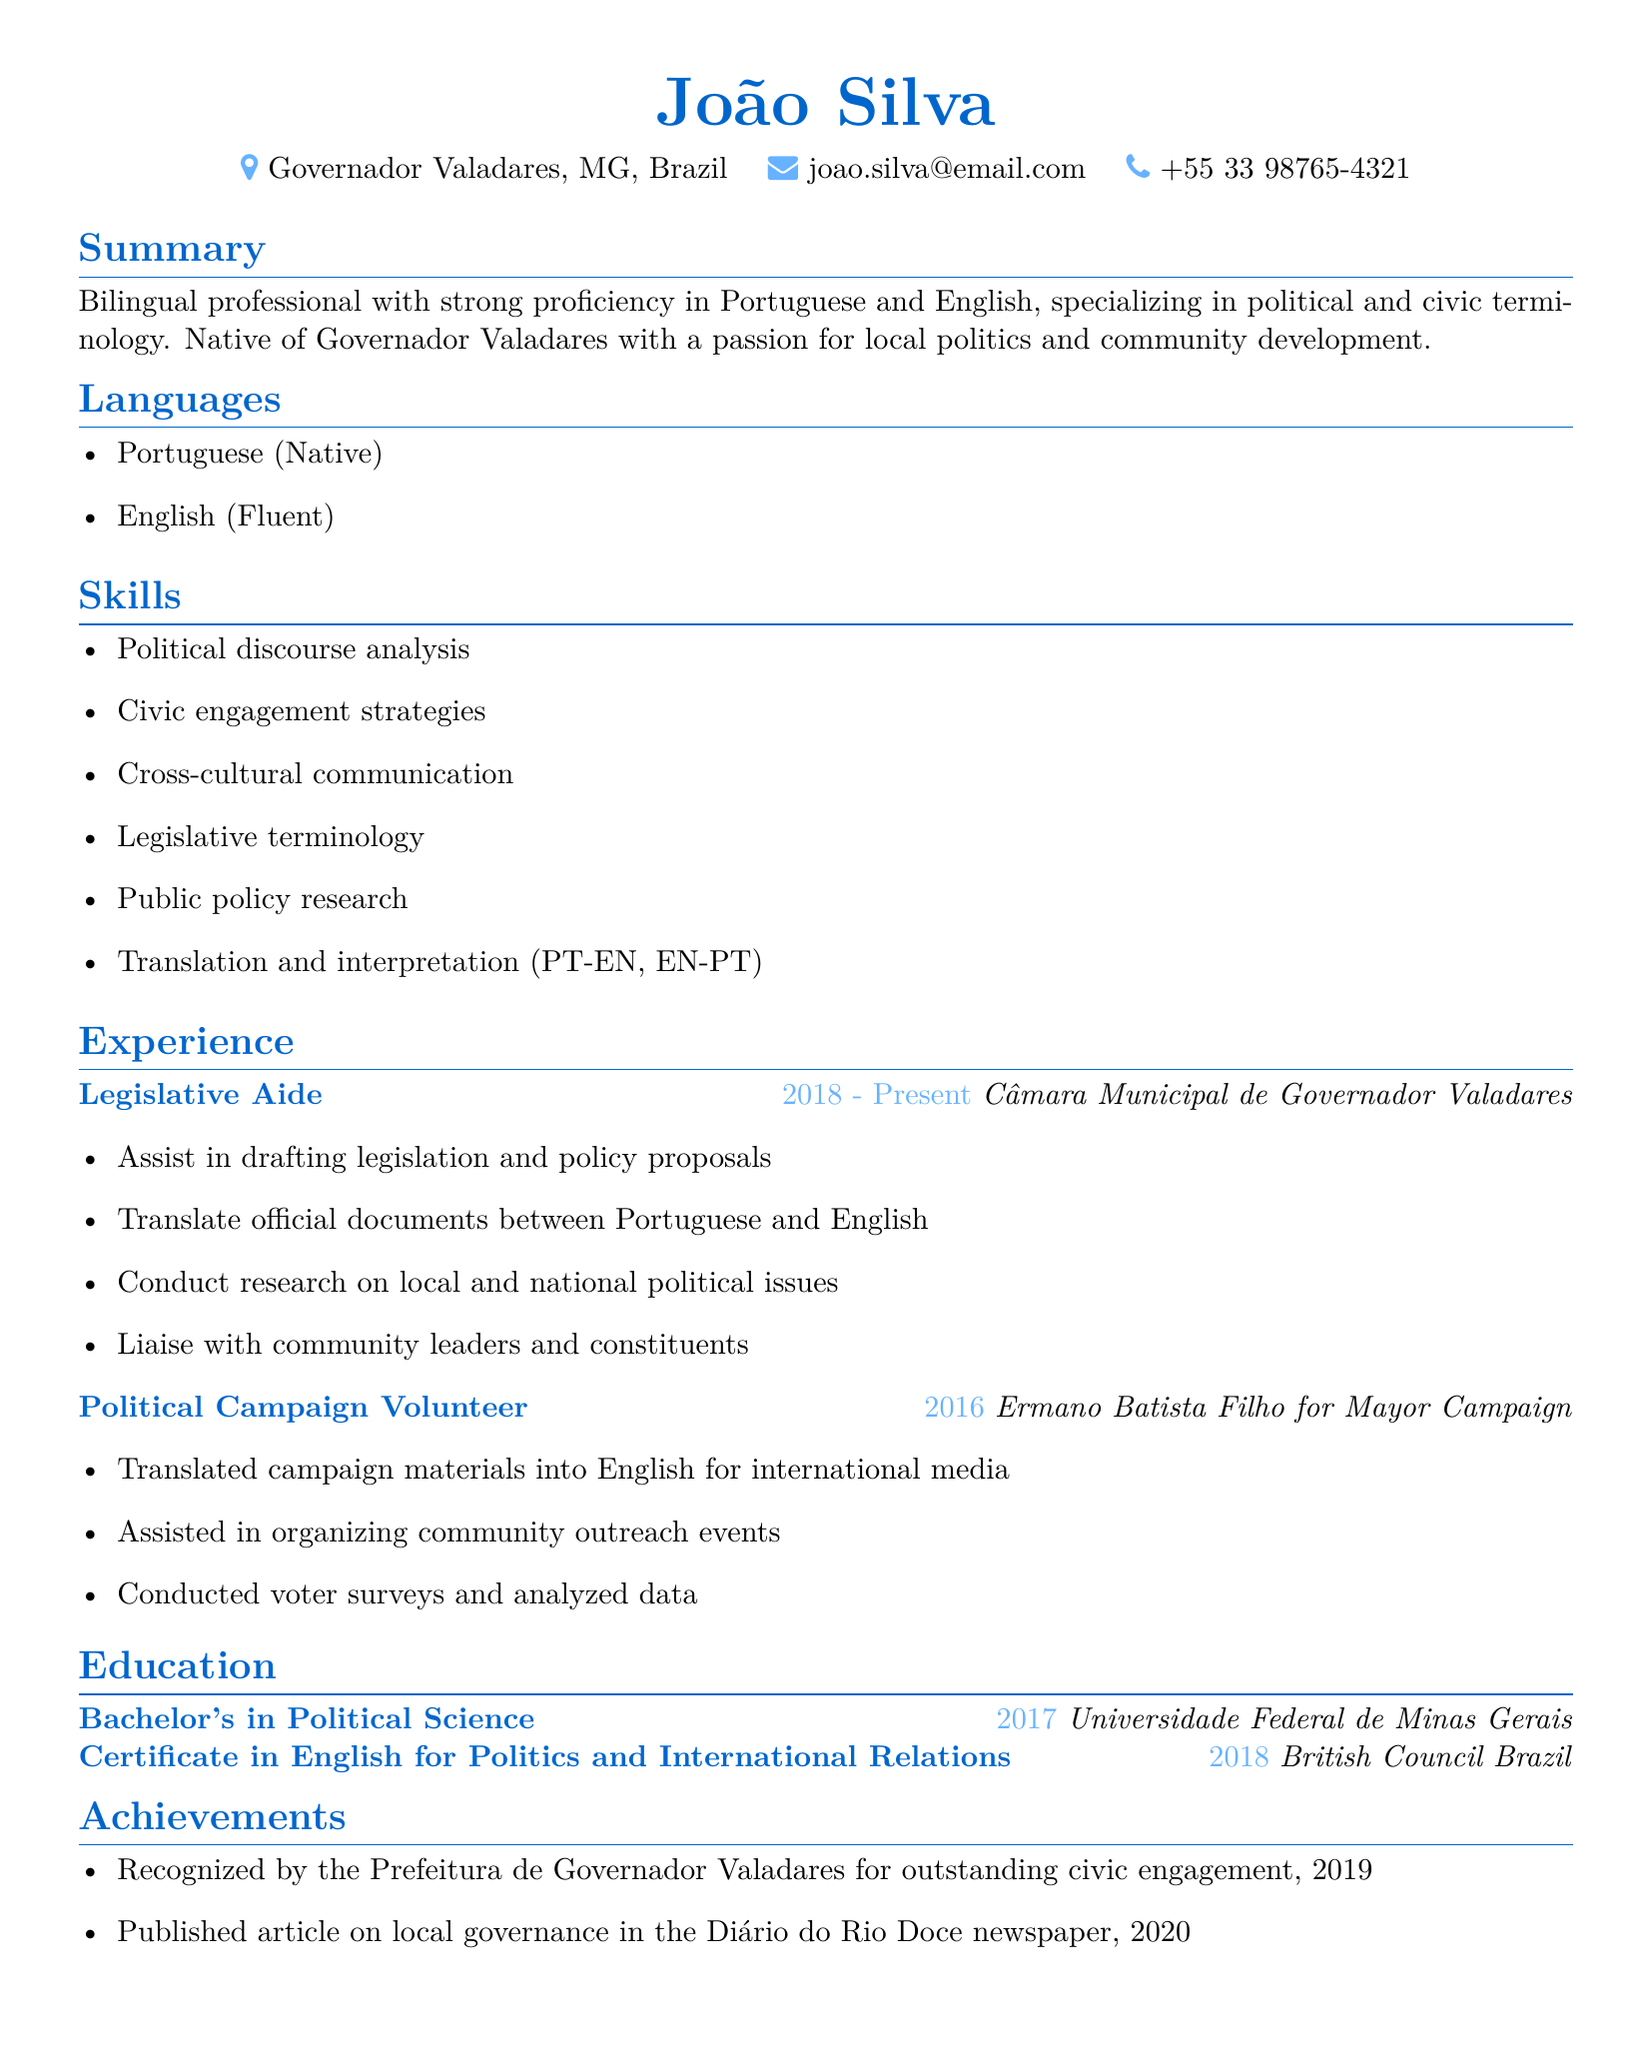What is João Silva's location? The location is stated in the personal info section of the resume.
Answer: Governador Valadares, Minas Gerais, Brazil What is João Silva's email address? The email address is provided in the personal info section.
Answer: joao.silva@email.com Which degree did João Silva earn? The educational background section lists the degree earned.
Answer: Bachelor's in Political Science What organization does João Silva currently work for? The current job title and organization are mentioned in the experience section.
Answer: Câmara Municipal de Governador Valadares What year did João Silva complete his degree? The education section includes the year of completion for his Bachelor's degree.
Answer: 2017 What was one of João Silva's responsibilities as a Legislative Aide? The responsibilities are outlined in the experience section for the role of Legislative Aide.
Answer: Assist in drafting legislation and policy proposals How many languages does João Silva speak? The languages section lists the languages spoken by João Silva.
Answer: Two In what year did João Silva receive recognition for outstanding civic engagement? The achievements section specifies when the recognition was received.
Answer: 2019 What type of certification did João Silva obtain in 2018? The education section describes the certification along with the institution.
Answer: Certificate in English for Politics and International Relations 